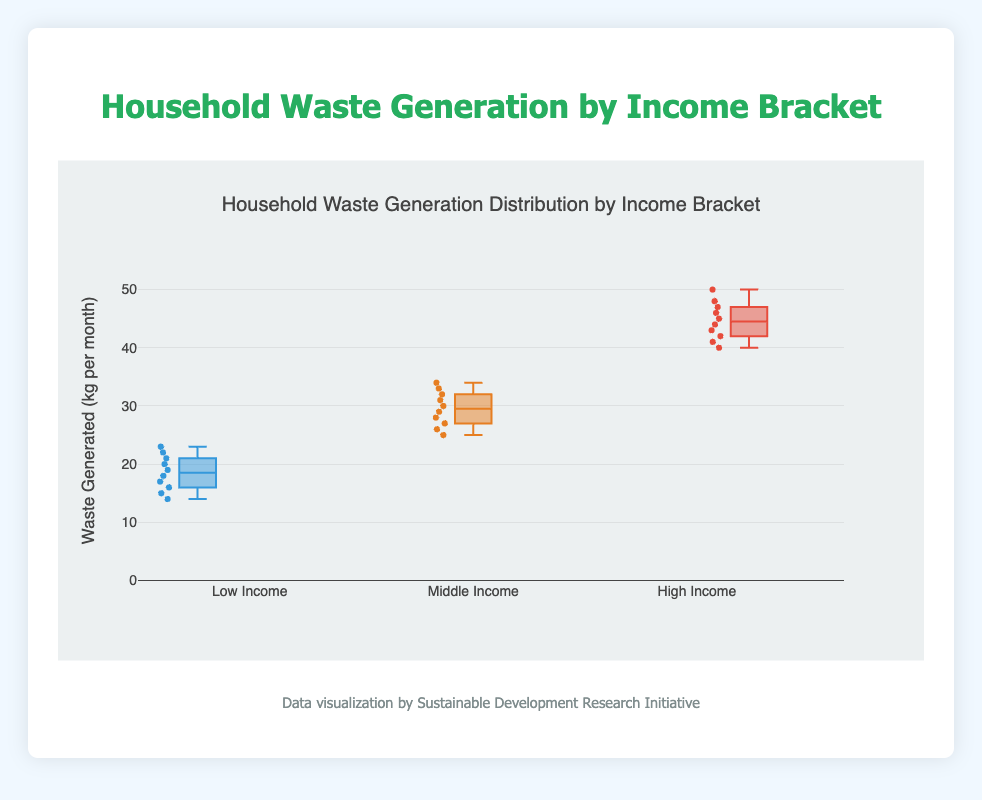What is the title of the figure? The title of the figure is shown at the top and reads "Household Waste Generation Distribution by Income Bracket."
Answer: Household Waste Generation Distribution by Income Bracket How many income brackets are compared in the plot? The plot has three distinct box plots, each representing a different income bracket: Low Income, Middle Income, and High Income.
Answer: Three What is the range of waste generated by the High Income group? For the High Income bracket, the data points indicate a range from the minimum (40 kg) to the maximum (50 kg).
Answer: 40 to 50 kg Which income bracket generates the most waste on average? Comparing the central tendency (median) of the box plots, the High Income group has the highest values, indicating they generate the most waste on average.
Answer: High Income What is the median waste generation for the Middle Income group? Observing the Middle Income box plot, the median or the center line of the box corresponds to 29.5 kg/month.
Answer: 29.5 kg/month Which income bracket has the widest range of waste generation? By comparing the range from the bottom to the top of the whiskers in each box plot, the High-Income bracket has the widest range (40 to 50 kg).
Answer: High Income Is the minimum waste generation greater in the Middle Income bracket compared to the Low Income bracket? The minimum value for Middle Income is 25 kg, and for Low Income, it is 14 kg. Hence, the minimum in Middle Income is greater.
Answer: Yes What is the interquartile range (IQR) for the Low Income group? The IQR is the difference between the third quartile (75th percentile) and the first quartile (25th percentile). For Low Income, these values are 21 kg and 16 kg respectively, so the IQR is 21 - 16 = 5 kg.
Answer: 5 kg Which income bracket has the smallest interquartile range (IQR)? Comparing the boxes' heights, Middle Income (IQR about 33.5 - 26.5 = 7) is the smallest among the three.
Answer: Middle Income Are there any outliers in the data? The box plots do not show any individual points outside the whiskers, indicating there are no outliers in any income bracket.
Answer: No 